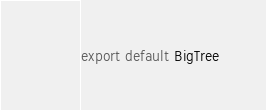<code> <loc_0><loc_0><loc_500><loc_500><_JavaScript_>export default BigTree
</code> 